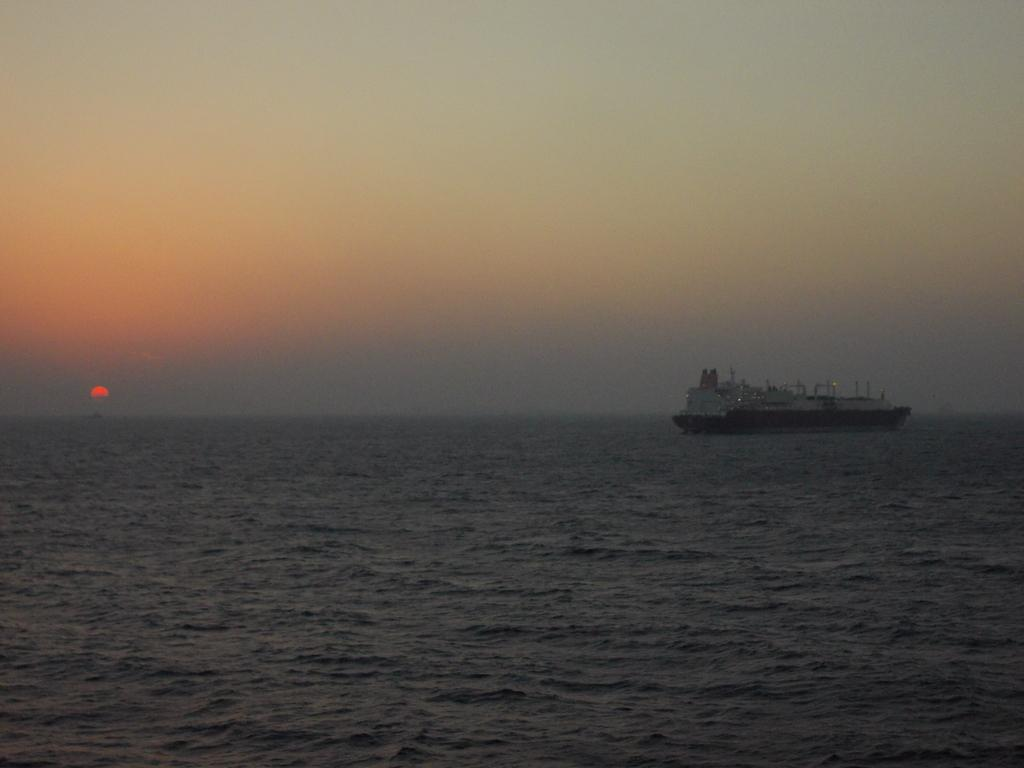What is the main subject of the image? The main subject of the image is a ship. Where is the ship located? The ship is on the ocean. What is happening in the sky in the image? The sun is setting in the image. What else can be seen in the image besides the ship and the sky? The sky is visible in the image. What type of property does the son own in the image? There is no son or property mentioned in the image; it features a ship on the ocean with a setting sun. 